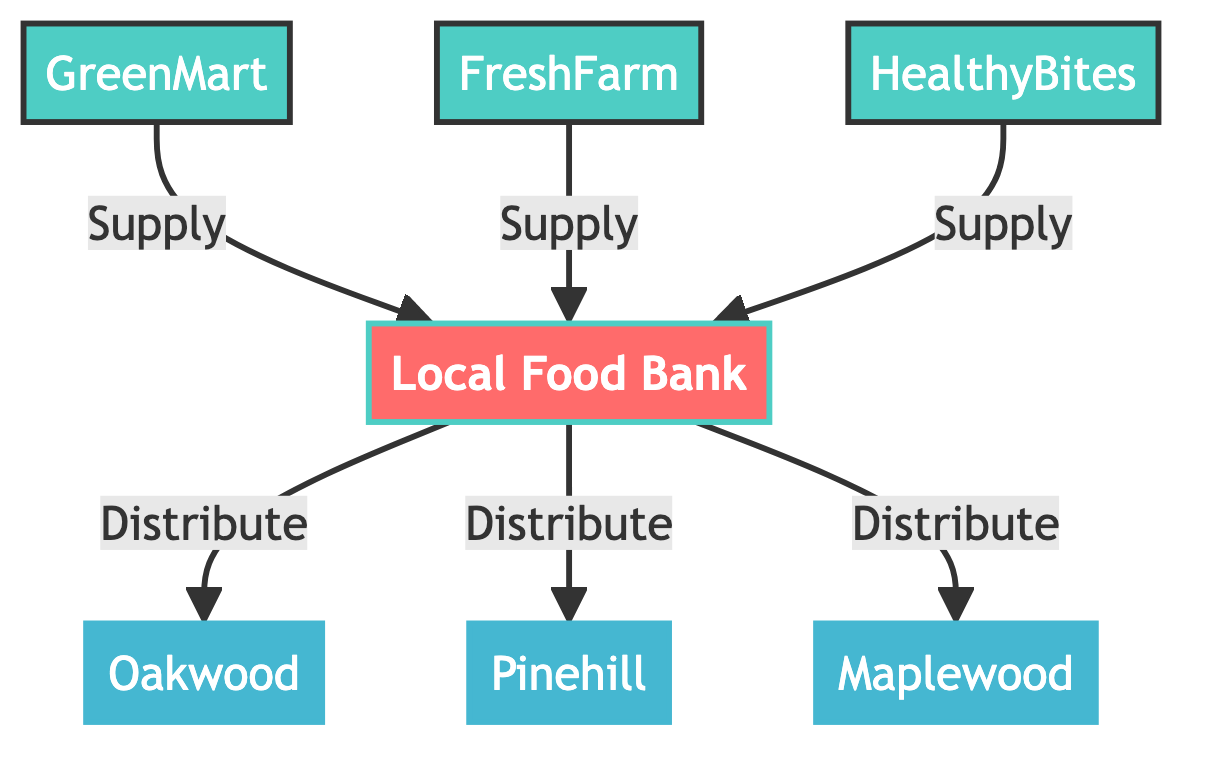What's the total number of nodes in the diagram? The diagram includes three types of nodes: one central node (Local Food Bank), three supply nodes (Grocery Store - GreenMart, Grocery Store - FreshFarm, Restaurant - HealthyBites), and three demand nodes (Community Center - Oakwood, Community Center - Pinehill, Community Center - Maplewood). Adding them up gives a total of 7 nodes.
Answer: 7 Which community center receives food from the Local Food Bank? The Local Food Bank distributes food to three community centers: Oakwood, Pinehill, and Maplewood. The diagram explicitly shows arrows from the Food Bank to each of these centers, indicating the flow of food distribution.
Answer: Oakwood, Pinehill, Maplewood How many supply links are present in the distribution network? There are three supply links from the grocery stores and restaurant to the Local Food Bank. The diagram specifically shows links from GreenMart, FreshFarm, and HealthyBites, totaling three links.
Answer: 3 What is the role of the Local Food Bank in the distribution network? The Local Food Bank serves as the central node that receives supplies from various sources (supply nodes) and distributes them to community centers (demand nodes). It connects all supply nodes to the demand nodes, acting as the main hub in the network.
Answer: Central hub Which supply node connects with HealthyBites? The HealthyBites restaurant connects to the Local Food Bank as a supply node. The diagram shows a link from HealthyBites to the Food Bank, confirming its role as a source of food supplies for redistribution.
Answer: Local Food Bank How many demand nodes are served by the Local Food Bank? The Local Food Bank serves three demand nodes: Oakwood, Pinehill, and Maplewood. The diagram indicates that the Food Bank distributes food to all these three centers, confirming their status as demand nodes.
Answer: 3 What type of node is FreshFarm in the network? FreshFarm is classified as a supply node in the network diagram. It provides food supplies to the Local Food Bank, which is evident from the directed link indicating supply from FreshFarm to the Food Bank.
Answer: Supply node What is the type of connection between the Food Bank and Community Center - Oakwood? The connection type between the Food Bank and Community Center - Oakwood is a distribution link. The diagram specifies this relationship, indicating that food is distributed from the Food Bank to this community center.
Answer: Distribution link 